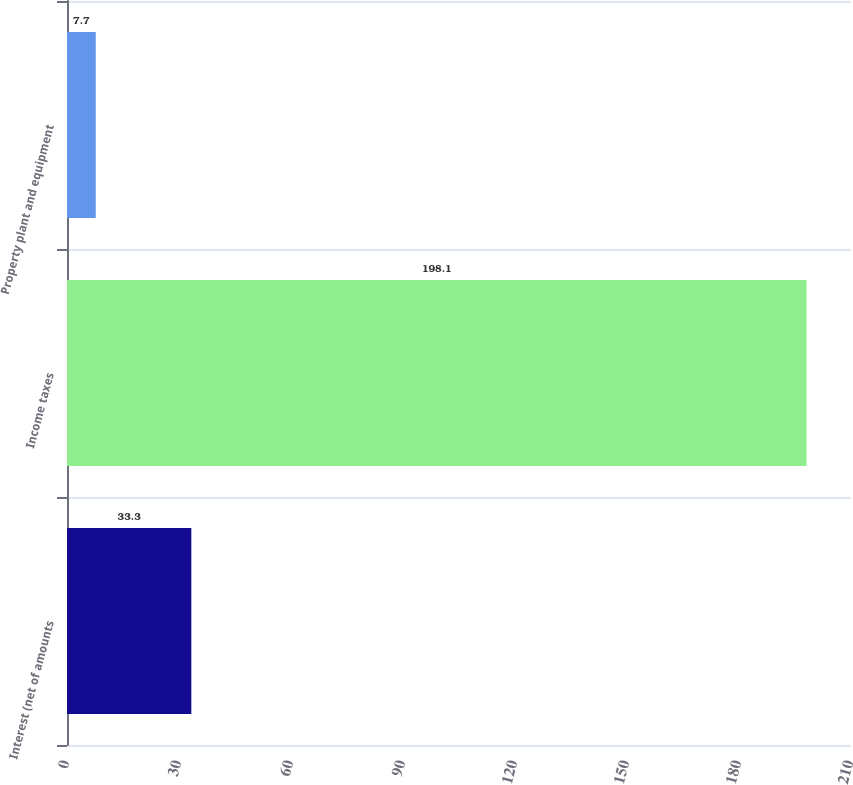Convert chart. <chart><loc_0><loc_0><loc_500><loc_500><bar_chart><fcel>Interest (net of amounts<fcel>Income taxes<fcel>Property plant and equipment<nl><fcel>33.3<fcel>198.1<fcel>7.7<nl></chart> 